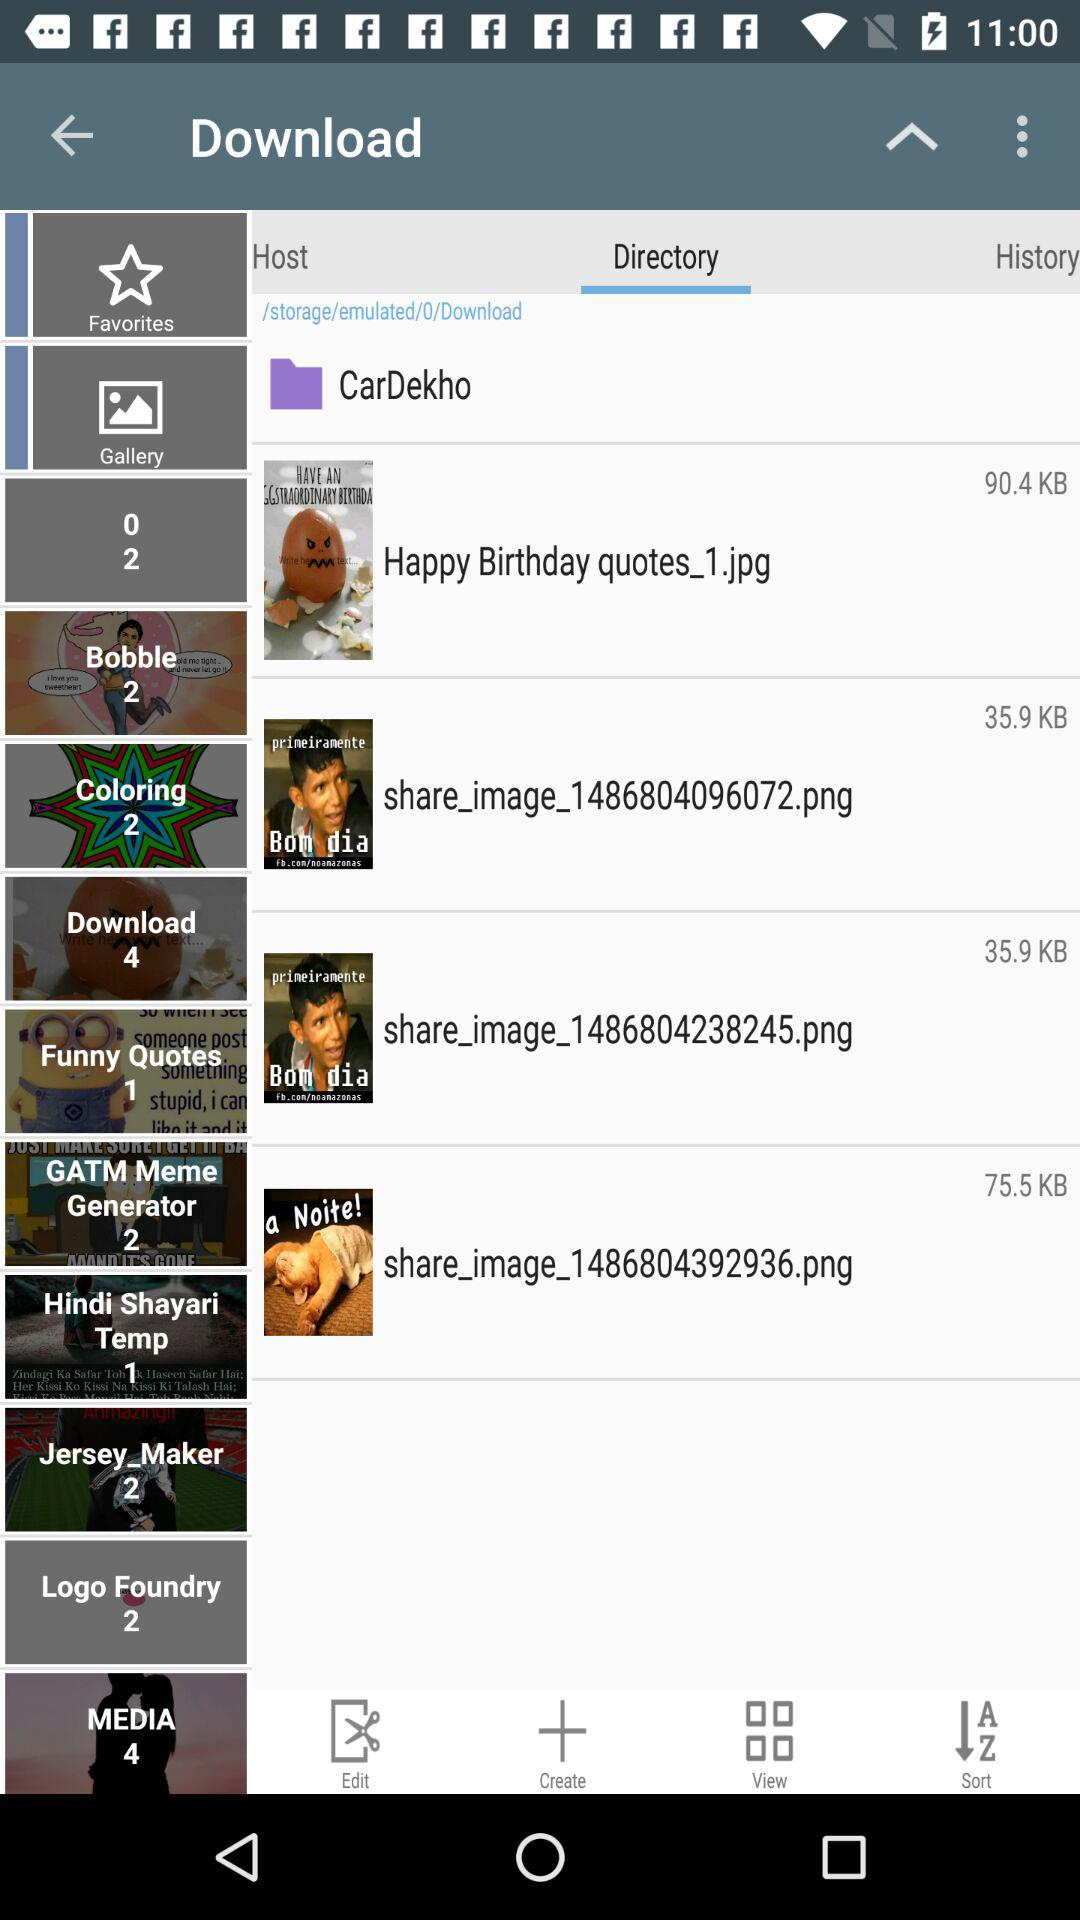What is the number of songs in the media? There are four songs in the media. 